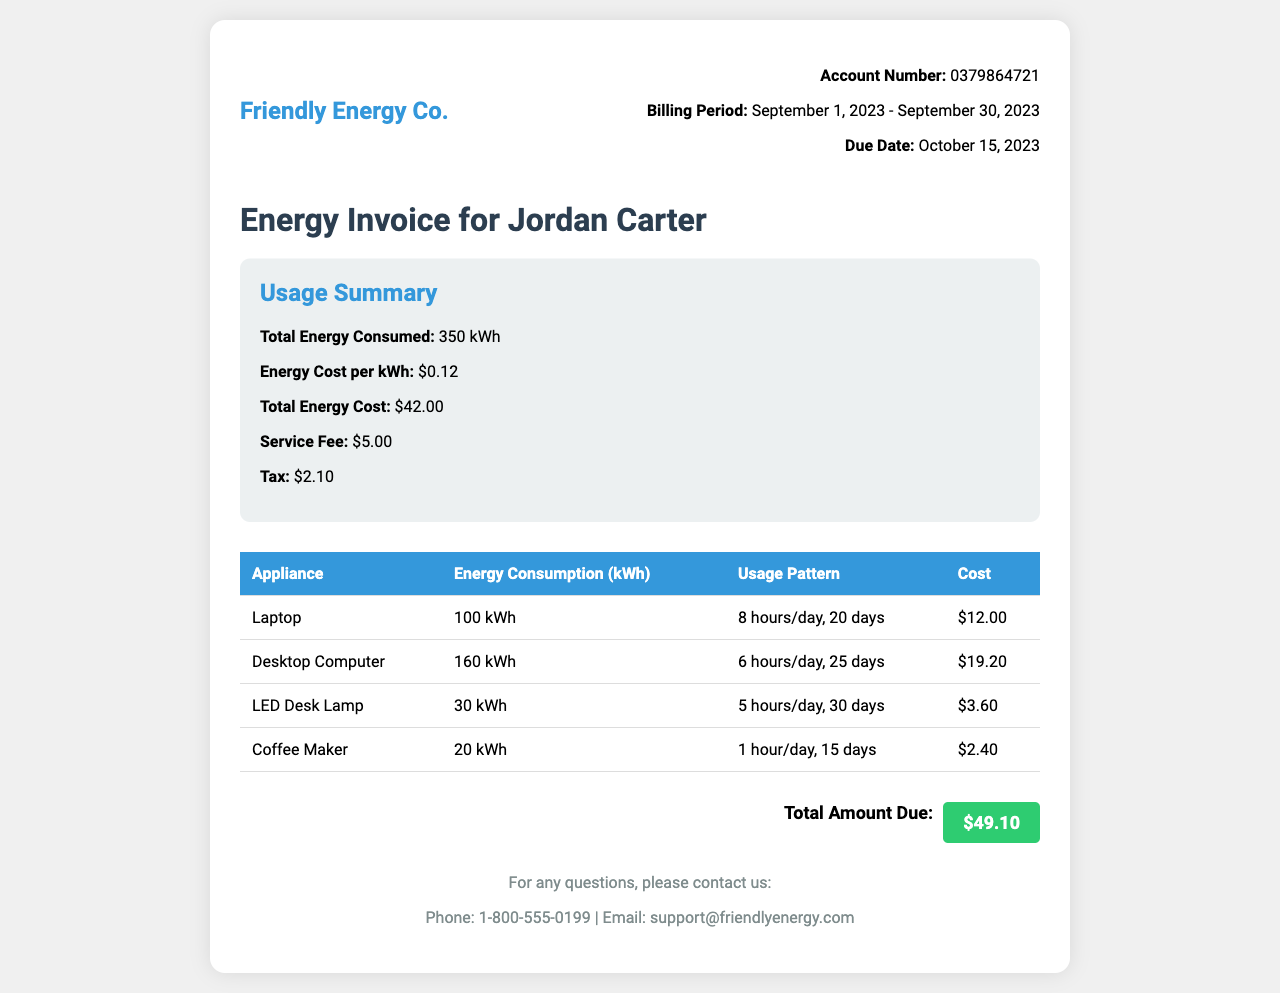What is the account number? The account number is mentioned in the invoice details section.
Answer: 0379864721 What is the billing period? The billing period is indicated at the top of the invoice.
Answer: September 1, 2023 - September 30, 2023 What is the total energy consumed? The total energy consumed is provided in the usage summary of the document.
Answer: 350 kWh What is the service fee? The service fee is listed in the usage summary section.
Answer: $5.00 How much is the energy cost per kWh? The energy cost per kWh is specified in the usage summary section of the invoice.
Answer: $0.12 Which appliance consumed the most energy? By comparing the energy consumption figures listed for each appliance, this can be determined.
Answer: Desktop Computer What is the total amount due? The total amount due is prominently displayed at the bottom of the invoice.
Answer: $49.10 What is the usage pattern for the LED Desk Lamp? The usage pattern for each appliance is provided in the table section.
Answer: 5 hours/day, 30 days What is the due date for this invoice? The due date is specified in the invoice details.
Answer: October 15, 2023 